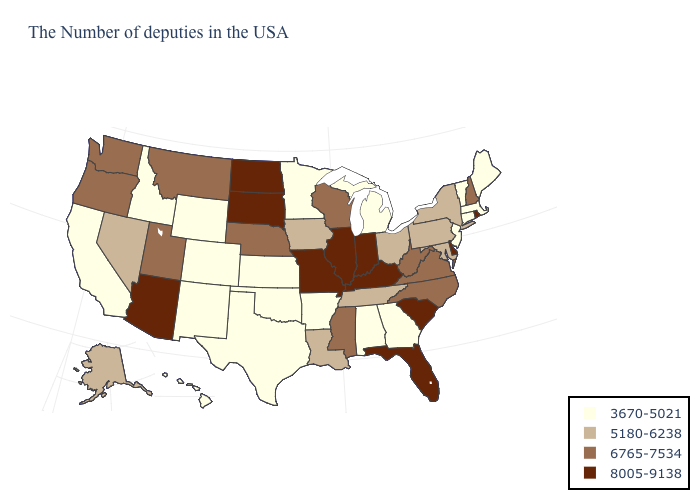Which states have the lowest value in the MidWest?
Be succinct. Michigan, Minnesota, Kansas. What is the value of Ohio?
Give a very brief answer. 5180-6238. Among the states that border Iowa , does Nebraska have the highest value?
Answer briefly. No. Does Kentucky have the highest value in the USA?
Quick response, please. Yes. What is the value of Nebraska?
Short answer required. 6765-7534. What is the highest value in states that border Mississippi?
Answer briefly. 5180-6238. Among the states that border Kansas , which have the lowest value?
Write a very short answer. Oklahoma, Colorado. Name the states that have a value in the range 3670-5021?
Quick response, please. Maine, Massachusetts, Vermont, Connecticut, New Jersey, Georgia, Michigan, Alabama, Arkansas, Minnesota, Kansas, Oklahoma, Texas, Wyoming, Colorado, New Mexico, Idaho, California, Hawaii. How many symbols are there in the legend?
Be succinct. 4. Name the states that have a value in the range 8005-9138?
Short answer required. Rhode Island, Delaware, South Carolina, Florida, Kentucky, Indiana, Illinois, Missouri, South Dakota, North Dakota, Arizona. Name the states that have a value in the range 5180-6238?
Keep it brief. New York, Maryland, Pennsylvania, Ohio, Tennessee, Louisiana, Iowa, Nevada, Alaska. What is the value of North Carolina?
Short answer required. 6765-7534. Among the states that border Nebraska , which have the lowest value?
Write a very short answer. Kansas, Wyoming, Colorado. Among the states that border Washington , does Oregon have the lowest value?
Answer briefly. No. What is the highest value in the USA?
Write a very short answer. 8005-9138. 